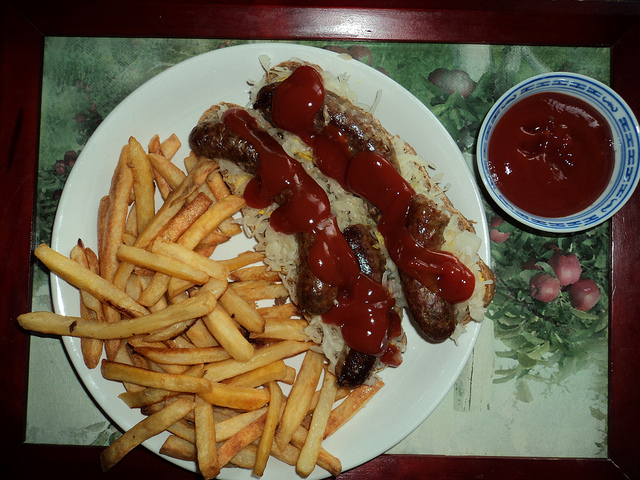<image>What meat topping is on the pizza? There is no pizza in the image. What meat topping is on the pizza? There is no pizza in the image. 